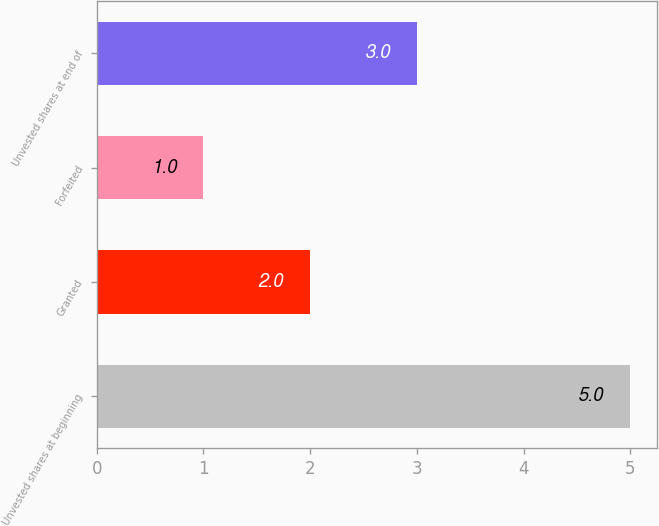Convert chart to OTSL. <chart><loc_0><loc_0><loc_500><loc_500><bar_chart><fcel>Unvested shares at beginning<fcel>Granted<fcel>Forfeited<fcel>Unvested shares at end of<nl><fcel>5<fcel>2<fcel>1<fcel>3<nl></chart> 